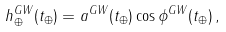<formula> <loc_0><loc_0><loc_500><loc_500>h _ { \oplus } ^ { G W } ( t _ { \oplus } ) = a ^ { G W } ( t _ { \oplus } ) \cos \phi ^ { G W } ( t _ { \oplus } ) \, ,</formula> 